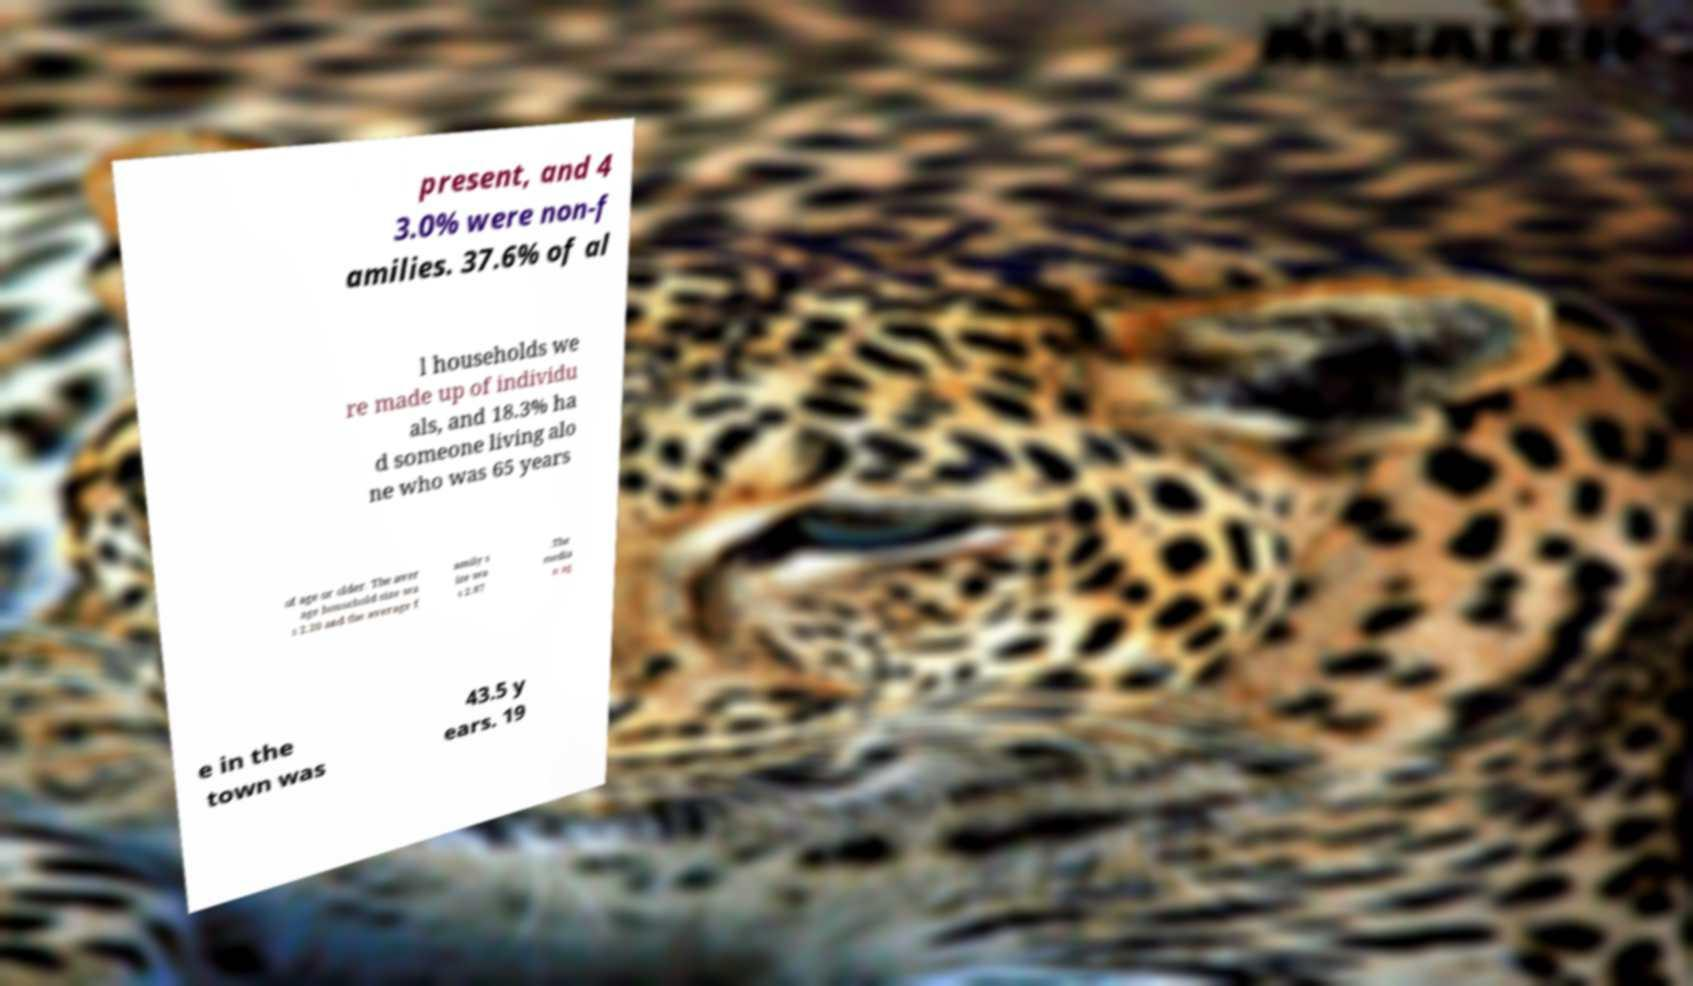For documentation purposes, I need the text within this image transcribed. Could you provide that? present, and 4 3.0% were non-f amilies. 37.6% of al l households we re made up of individu als, and 18.3% ha d someone living alo ne who was 65 years of age or older. The aver age household size wa s 2.20 and the average f amily s ize wa s 2.87 .The media n ag e in the town was 43.5 y ears. 19 